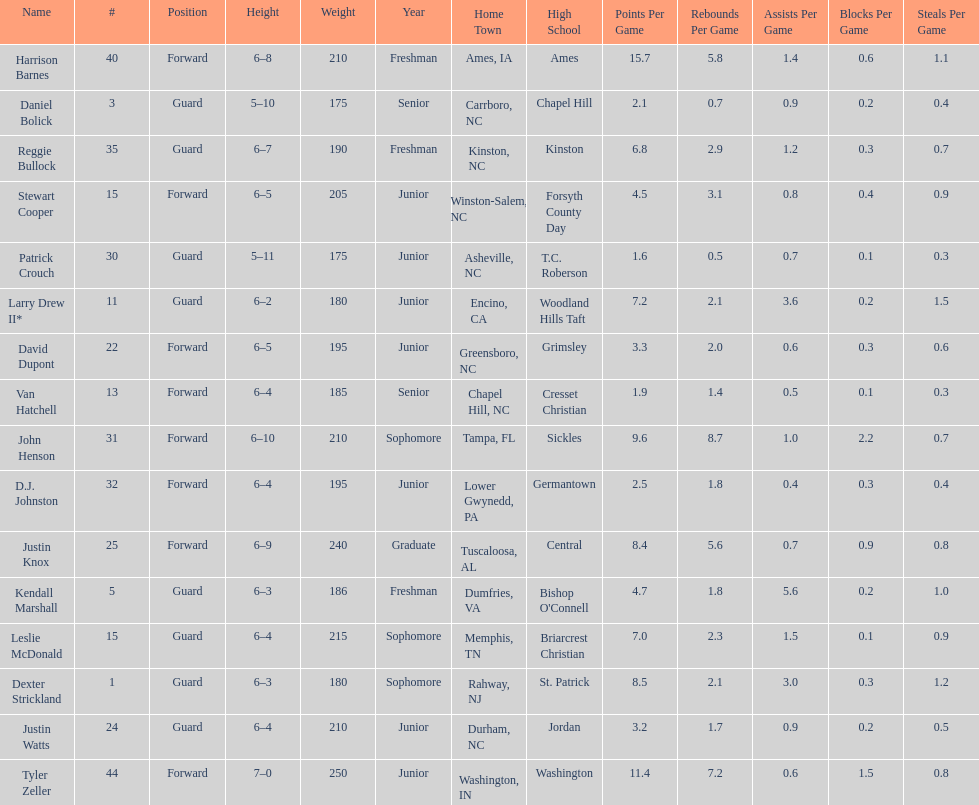How many players have a weight exceeding 200? 7. 